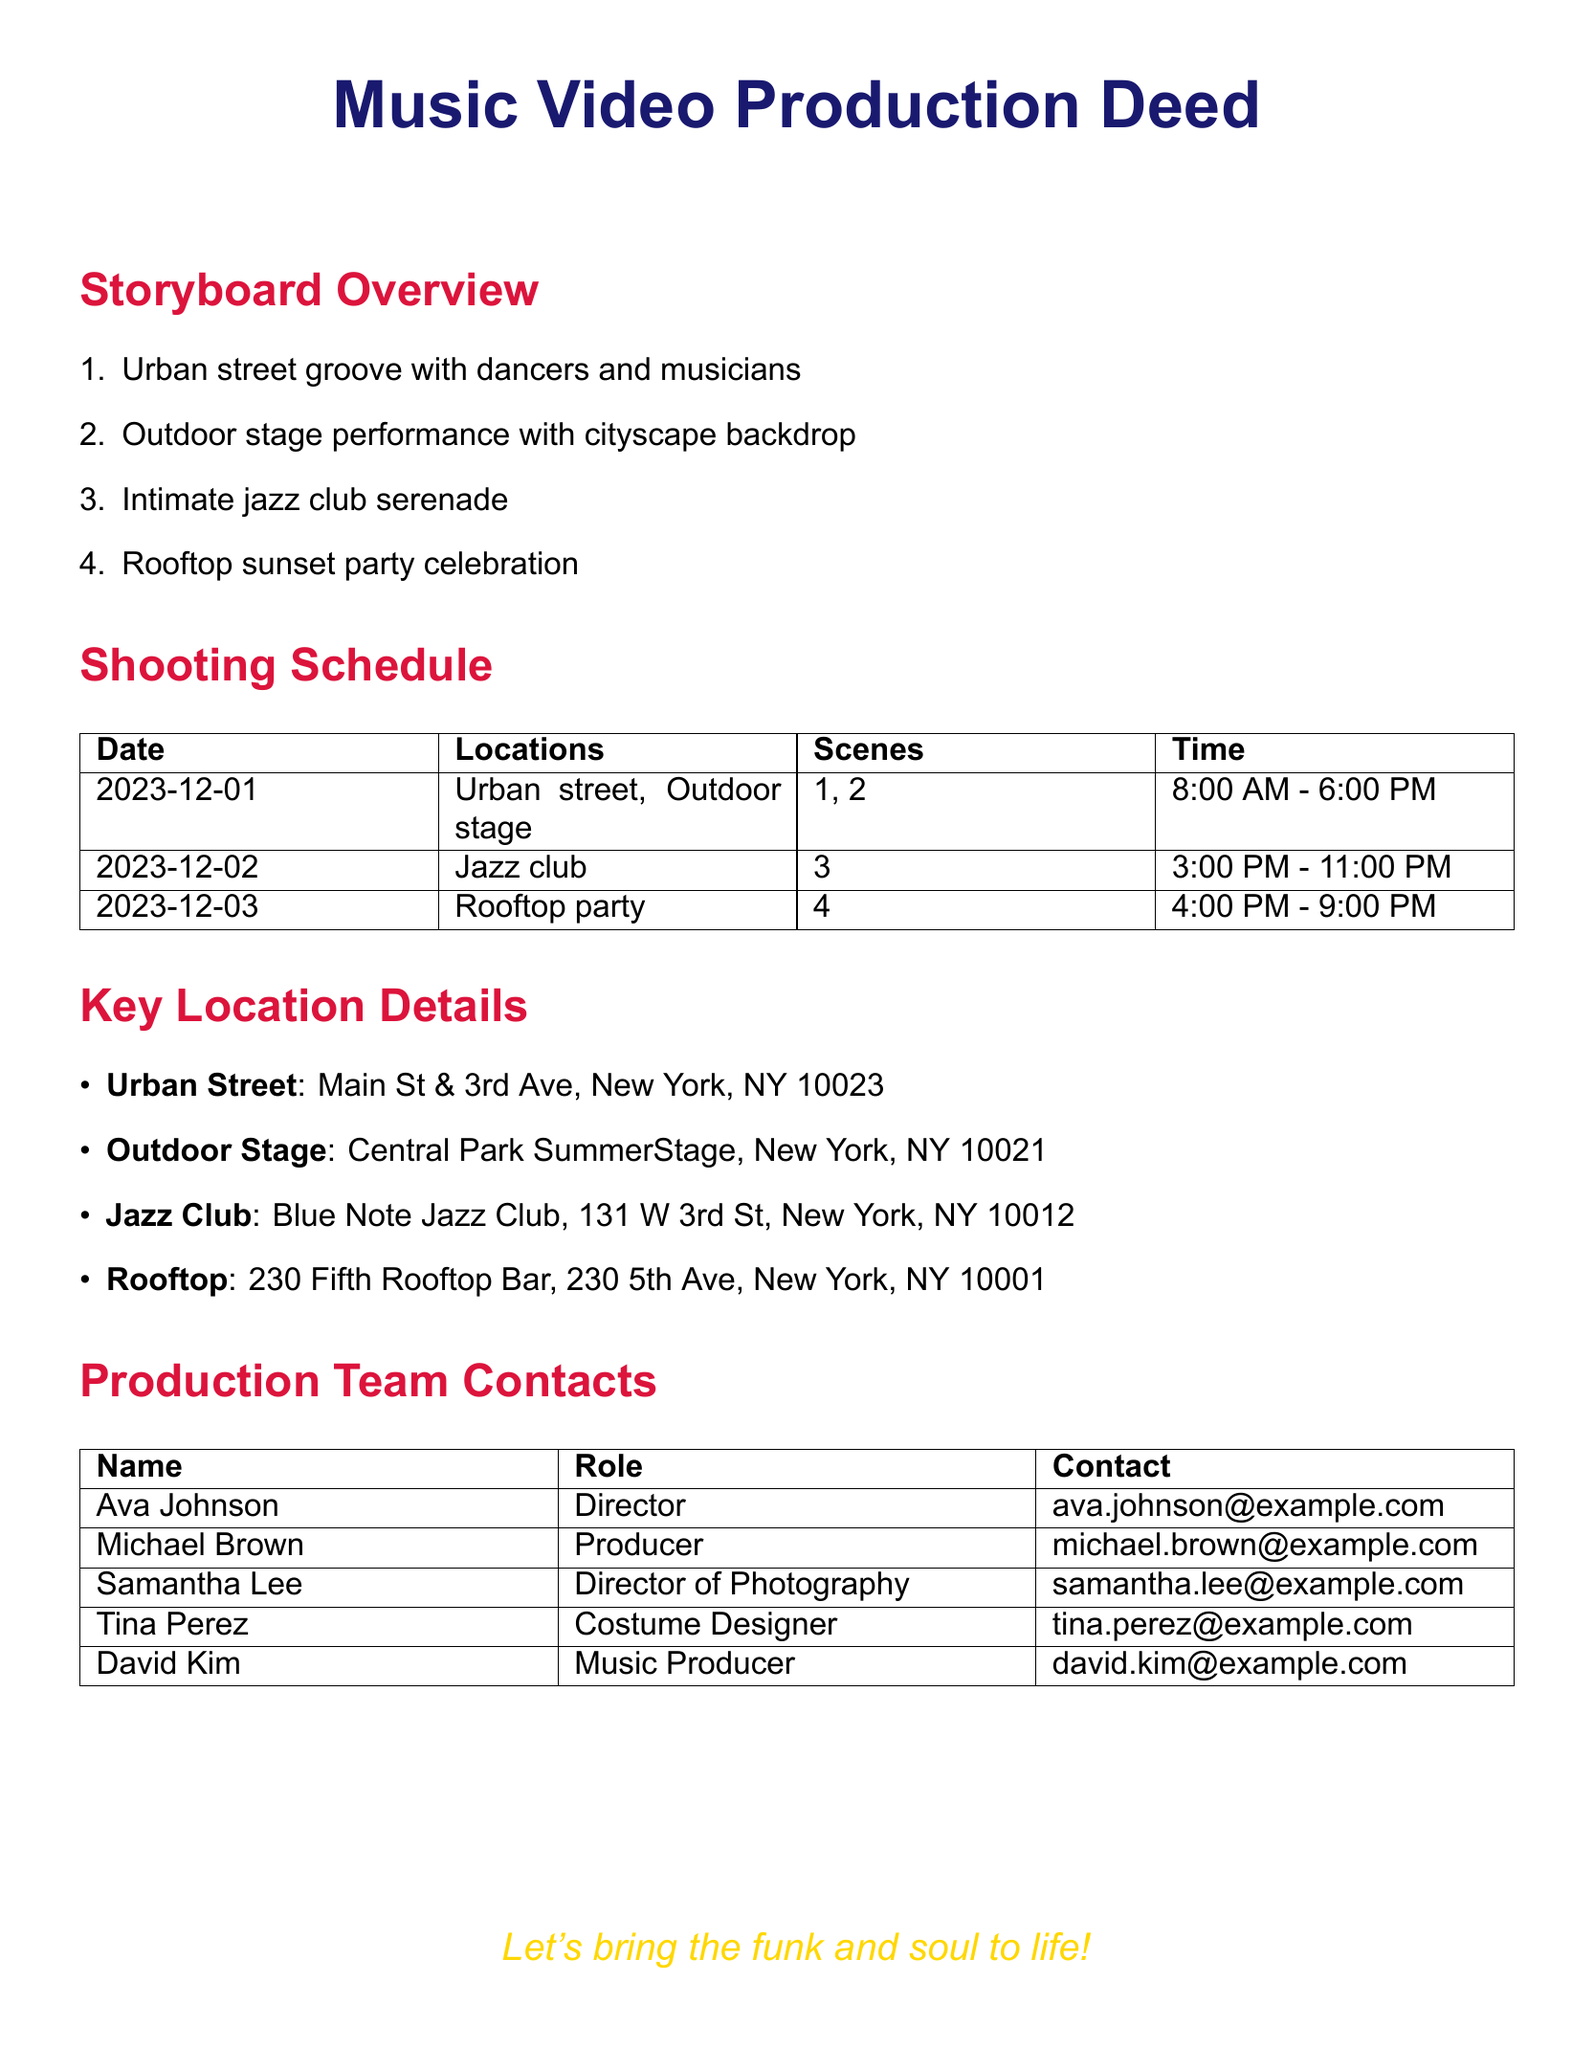What is the title of the document? The title of the document is stated at the beginning in a larger font, which identifies it as the Music Video Production Deed.
Answer: Music Video Production Deed How many scenes are planned for the shooting schedule? The number of scenes is listed in the storyboard overview, which mentions four distinct scenes.
Answer: 4 What date is the outdoor stage shoot scheduled for? The date for the outdoor stage shoot is specified in the shooting schedule table, listing it as December 1, 2023.
Answer: 2023-12-01 What is the contact email for the Director? The contact information for the Director is found in the Production Team Contacts section, stating Ava Johnson's email.
Answer: ava.johnson@example.com What location is the jazz club shoot taking place at? The location for the jazz club shoot is detailed under Key Location Details, identifying the Blue Note Jazz Club as the venue.
Answer: Blue Note Jazz Club On which date will the rooftop party scene be filmed? The filming date for the rooftop party scene is provided in the shooting schedule, noting it as December 3, 2023.
Answer: 2023-12-03 What role does Samantha Lee have in the production? Samantha Lee's role is identified in the Production Team Contacts table, where she is noted as the Director of Photography.
Answer: Director of Photography What is the backdrop for scene 2 in the storyboard? The storyboard outlines the outdoor stage performance as the second scene, which features a cityscape backdrop.
Answer: cityscape backdrop What is the address of the rooftop location? The address for the rooftop location can be found under Key Location Details, specifying 230 5th Ave, New York, NY 10001.
Answer: 230 5th Ave, New York, NY 10001 